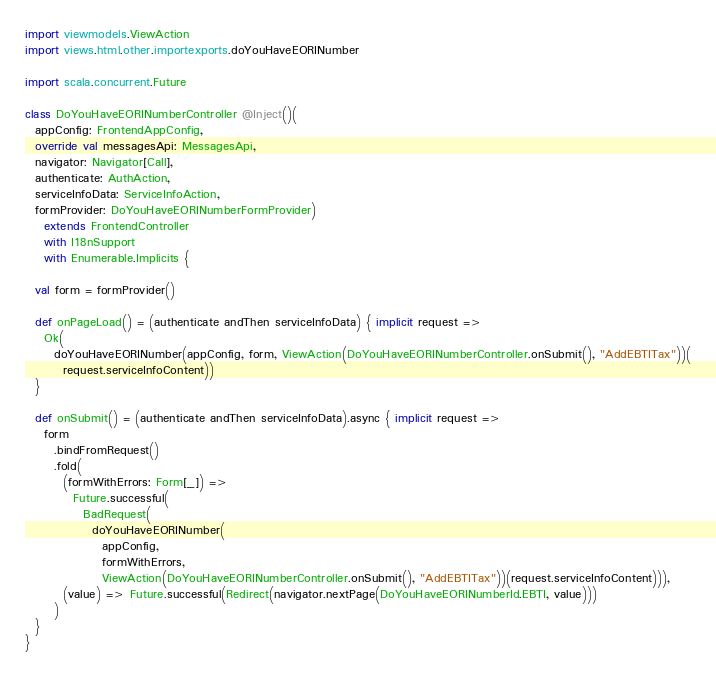<code> <loc_0><loc_0><loc_500><loc_500><_Scala_>import viewmodels.ViewAction
import views.html.other.importexports.doYouHaveEORINumber

import scala.concurrent.Future

class DoYouHaveEORINumberController @Inject()(
  appConfig: FrontendAppConfig,
  override val messagesApi: MessagesApi,
  navigator: Navigator[Call],
  authenticate: AuthAction,
  serviceInfoData: ServiceInfoAction,
  formProvider: DoYouHaveEORINumberFormProvider)
    extends FrontendController
    with I18nSupport
    with Enumerable.Implicits {

  val form = formProvider()

  def onPageLoad() = (authenticate andThen serviceInfoData) { implicit request =>
    Ok(
      doYouHaveEORINumber(appConfig, form, ViewAction(DoYouHaveEORINumberController.onSubmit(), "AddEBTITax"))(
        request.serviceInfoContent))
  }

  def onSubmit() = (authenticate andThen serviceInfoData).async { implicit request =>
    form
      .bindFromRequest()
      .fold(
        (formWithErrors: Form[_]) =>
          Future.successful(
            BadRequest(
              doYouHaveEORINumber(
                appConfig,
                formWithErrors,
                ViewAction(DoYouHaveEORINumberController.onSubmit(), "AddEBTITax"))(request.serviceInfoContent))),
        (value) => Future.successful(Redirect(navigator.nextPage(DoYouHaveEORINumberId.EBTI, value)))
      )
  }
}
</code> 